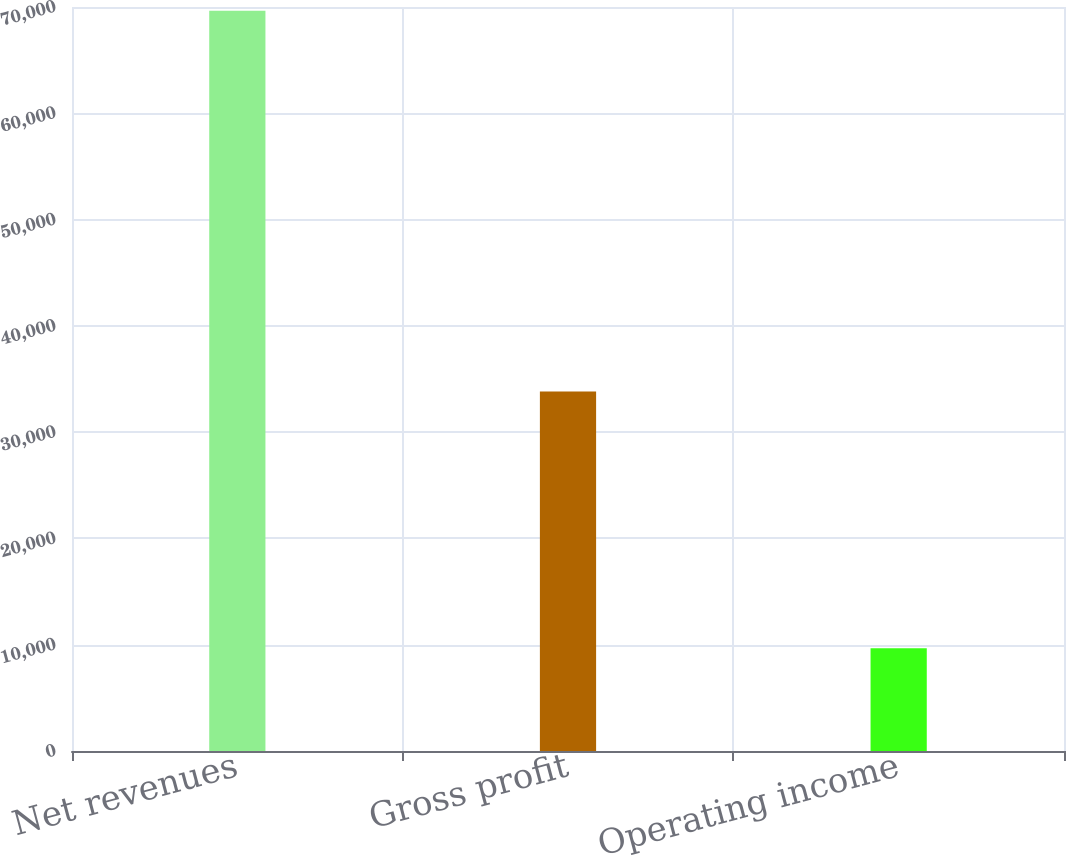Convert chart. <chart><loc_0><loc_0><loc_500><loc_500><bar_chart><fcel>Net revenues<fcel>Gross profit<fcel>Operating income<nl><fcel>69645<fcel>33817<fcel>9668<nl></chart> 